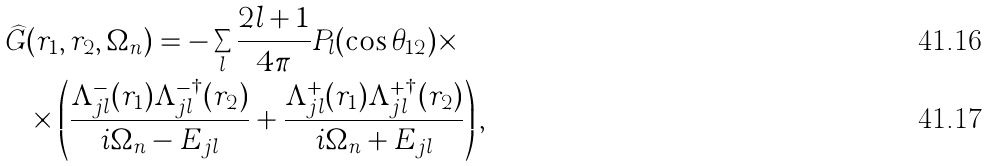Convert formula to latex. <formula><loc_0><loc_0><loc_500><loc_500>\widehat { G } & ( r _ { 1 } , r _ { 2 } , \Omega _ { n } ) = - \sum _ { l } \frac { 2 l + 1 } { 4 \pi } P _ { l } ( \cos \theta _ { 1 2 } ) \times \\ & \times \left ( \frac { \Lambda _ { j l } ^ { - } ( r _ { 1 } ) \Lambda _ { j l } ^ { - \dagger } ( r _ { 2 } ) } { i \Omega _ { n } - E _ { j l } } + \frac { \Lambda _ { j l } ^ { + } ( r _ { 1 } ) \Lambda _ { j l } ^ { + \dagger } ( r _ { 2 } ) } { i \Omega _ { n } + E _ { j l } } \right ) ,</formula> 